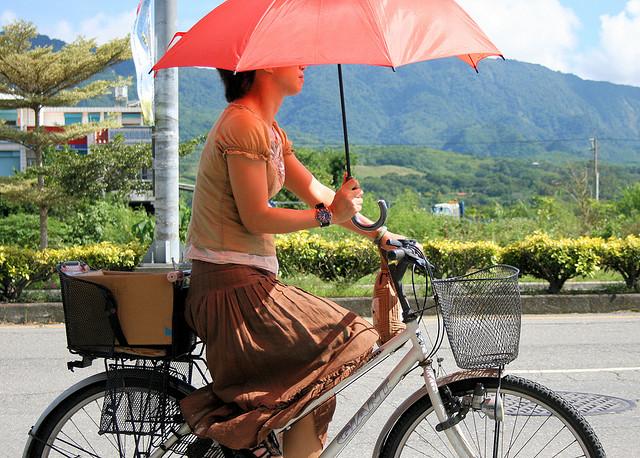What color is the umbrella?
Short answer required. Red. What is in the basket of the bike?
Write a very short answer. Nothing. Is there a basket on her bike?
Write a very short answer. Yes. What is the lady doing?
Short answer required. Riding bike. 